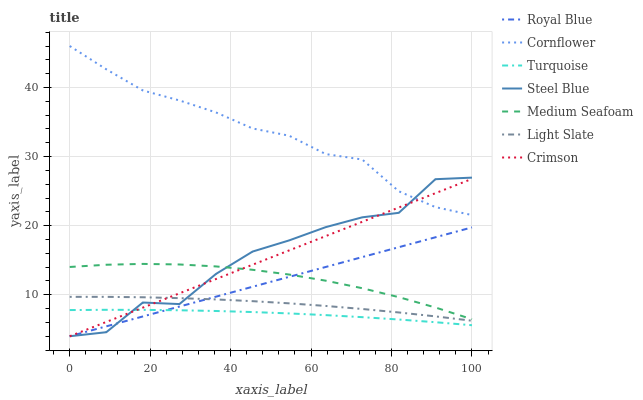Does Turquoise have the minimum area under the curve?
Answer yes or no. Yes. Does Cornflower have the maximum area under the curve?
Answer yes or no. Yes. Does Light Slate have the minimum area under the curve?
Answer yes or no. No. Does Light Slate have the maximum area under the curve?
Answer yes or no. No. Is Crimson the smoothest?
Answer yes or no. Yes. Is Steel Blue the roughest?
Answer yes or no. Yes. Is Turquoise the smoothest?
Answer yes or no. No. Is Turquoise the roughest?
Answer yes or no. No. Does Steel Blue have the lowest value?
Answer yes or no. Yes. Does Turquoise have the lowest value?
Answer yes or no. No. Does Cornflower have the highest value?
Answer yes or no. Yes. Does Light Slate have the highest value?
Answer yes or no. No. Is Royal Blue less than Cornflower?
Answer yes or no. Yes. Is Cornflower greater than Royal Blue?
Answer yes or no. Yes. Does Steel Blue intersect Crimson?
Answer yes or no. Yes. Is Steel Blue less than Crimson?
Answer yes or no. No. Is Steel Blue greater than Crimson?
Answer yes or no. No. Does Royal Blue intersect Cornflower?
Answer yes or no. No. 